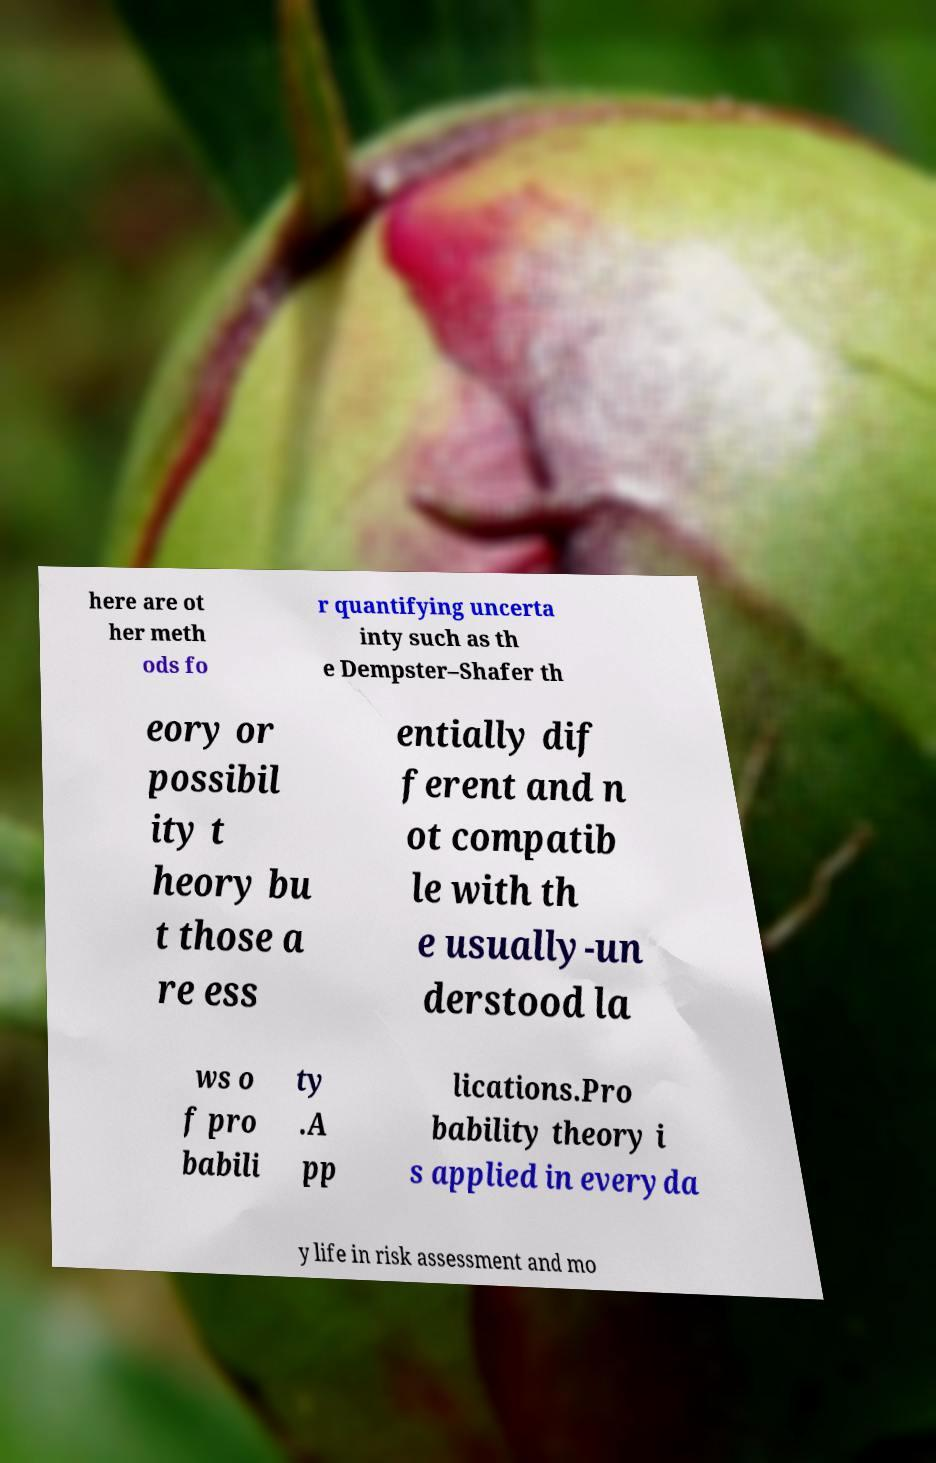What messages or text are displayed in this image? I need them in a readable, typed format. here are ot her meth ods fo r quantifying uncerta inty such as th e Dempster–Shafer th eory or possibil ity t heory bu t those a re ess entially dif ferent and n ot compatib le with th e usually-un derstood la ws o f pro babili ty .A pp lications.Pro bability theory i s applied in everyda y life in risk assessment and mo 